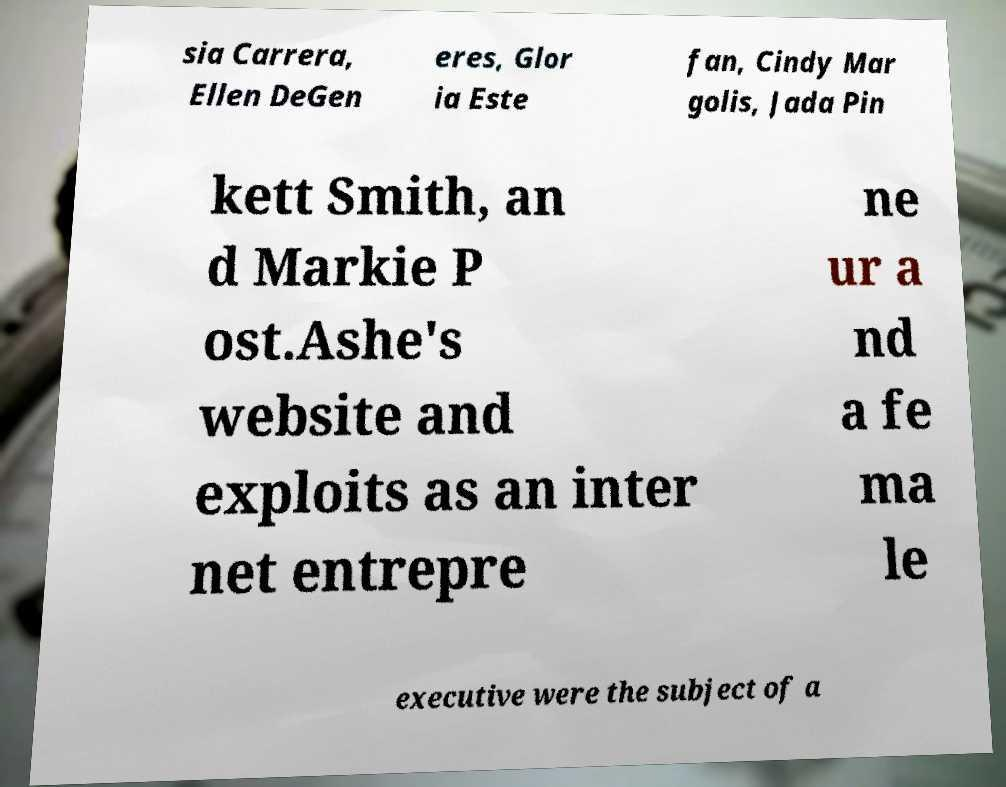Can you read and provide the text displayed in the image?This photo seems to have some interesting text. Can you extract and type it out for me? sia Carrera, Ellen DeGen eres, Glor ia Este fan, Cindy Mar golis, Jada Pin kett Smith, an d Markie P ost.Ashe's website and exploits as an inter net entrepre ne ur a nd a fe ma le executive were the subject of a 